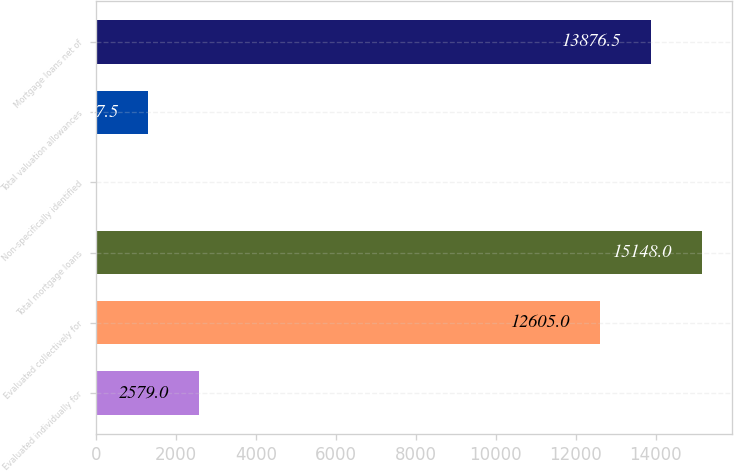Convert chart. <chart><loc_0><loc_0><loc_500><loc_500><bar_chart><fcel>Evaluated individually for<fcel>Evaluated collectively for<fcel>Total mortgage loans<fcel>Non-specifically identified<fcel>Total valuation allowances<fcel>Mortgage loans net of<nl><fcel>2579<fcel>12605<fcel>15148<fcel>36<fcel>1307.5<fcel>13876.5<nl></chart> 